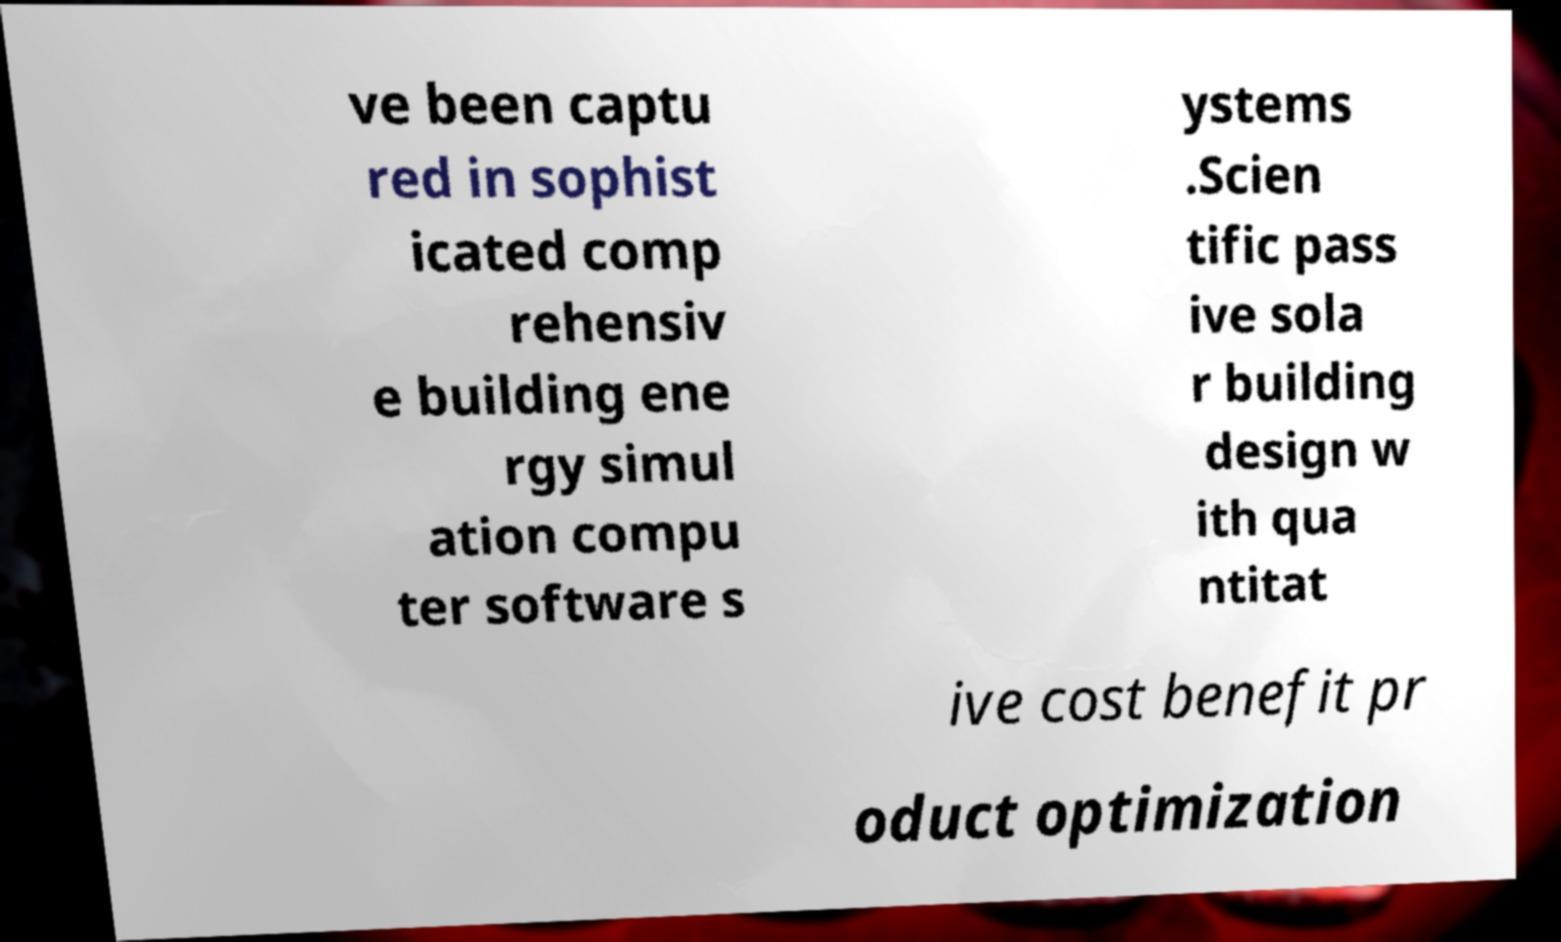Could you assist in decoding the text presented in this image and type it out clearly? ve been captu red in sophist icated comp rehensiv e building ene rgy simul ation compu ter software s ystems .Scien tific pass ive sola r building design w ith qua ntitat ive cost benefit pr oduct optimization 